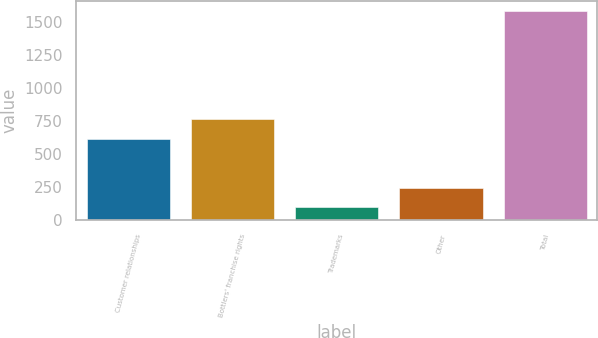Convert chart. <chart><loc_0><loc_0><loc_500><loc_500><bar_chart><fcel>Customer relationships<fcel>Bottlers' franchise rights<fcel>Trademarks<fcel>Other<fcel>Total<nl><fcel>619<fcel>767.3<fcel>99<fcel>247.3<fcel>1582<nl></chart> 